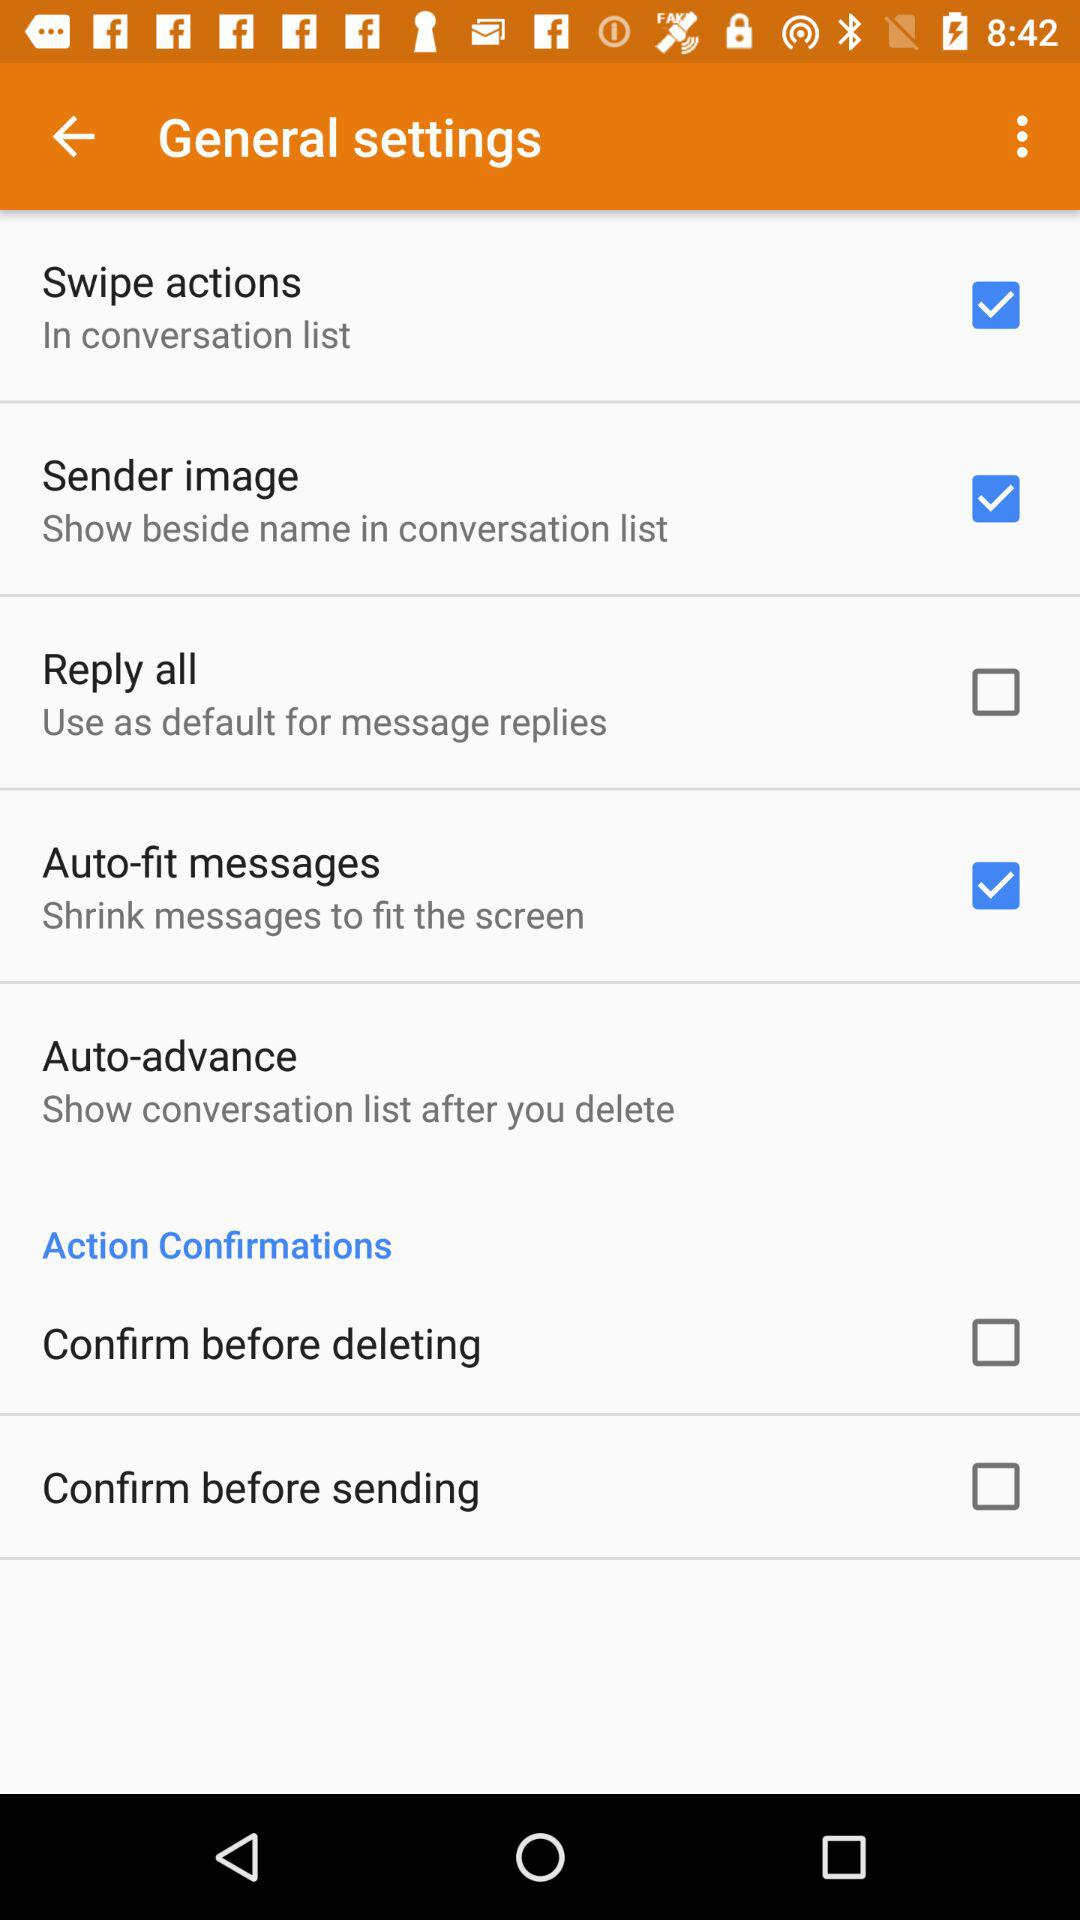Where beside name can mentioned in sender image?
When the provided information is insufficient, respond with <no answer>. <no answer> 